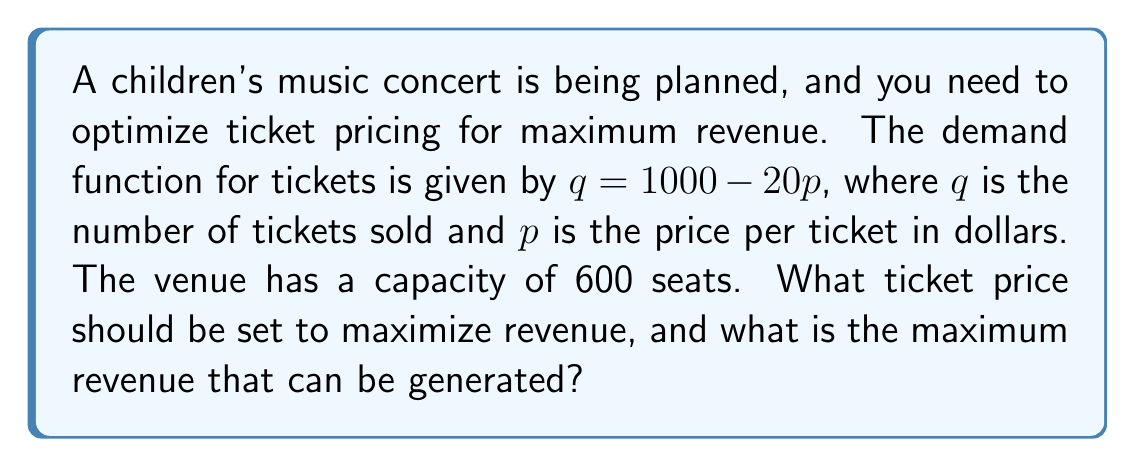Could you help me with this problem? Let's approach this step-by-step:

1) The revenue function $R$ is given by price times quantity:
   $R = pq = p(1000 - 20p) = 1000p - 20p^2$

2) To find the maximum revenue, we need to find the derivative of $R$ with respect to $p$ and set it to zero:
   $$\frac{dR}{dp} = 1000 - 40p$$
   
3) Setting this equal to zero:
   $1000 - 40p = 0$
   $40p = 1000$
   $p = 25$

4) This gives us a critical point at $p = 25$. We can verify it's a maximum by checking the second derivative:
   $$\frac{d^2R}{dp^2} = -40 < 0$$
   Since this is negative, $p = 25$ indeed gives a maximum.

5) At $p = 25$, the quantity sold would be:
   $q = 1000 - 20(25) = 500$

6) This is within the venue capacity of 600, so it's feasible.

7) The maximum revenue is therefore:
   $R = 25 * 500 = 12,500$

To tie this back to our music-loving accountant persona: Just as children's songs often have a sweet spot in terms of complexity that maximizes enjoyment, we've found the sweet spot for ticket pricing that maximizes revenue!
Answer: The optimal ticket price is $25, and the maximum revenue that can be generated is $12,500. 